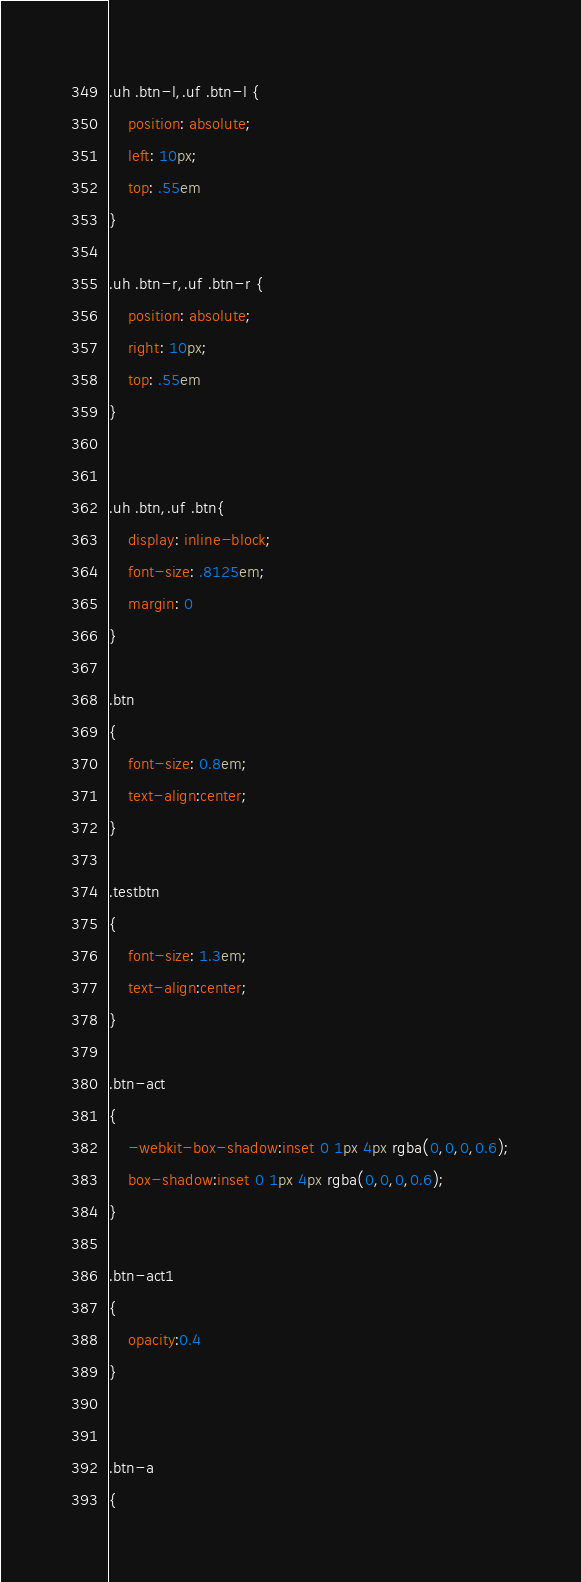<code> <loc_0><loc_0><loc_500><loc_500><_CSS_>
.uh .btn-l,.uf .btn-l {
	position: absolute;
	left: 10px;
	top: .55em
}

.uh .btn-r,.uf .btn-r {
	position: absolute;
	right: 10px;
	top: .55em
}


.uh .btn,.uf .btn{
	display: inline-block;
	font-size: .8125em;
	margin: 0
}

.btn
{
	font-size: 0.8em;
	text-align:center;
}

.testbtn
{
	font-size: 1.3em;
	text-align:center;
}

.btn-act
{
	-webkit-box-shadow:inset 0 1px 4px rgba(0,0,0,0.6);
	box-shadow:inset 0 1px 4px rgba(0,0,0,0.6);
}

.btn-act1
{
	opacity:0.4
}


.btn-a
{</code> 